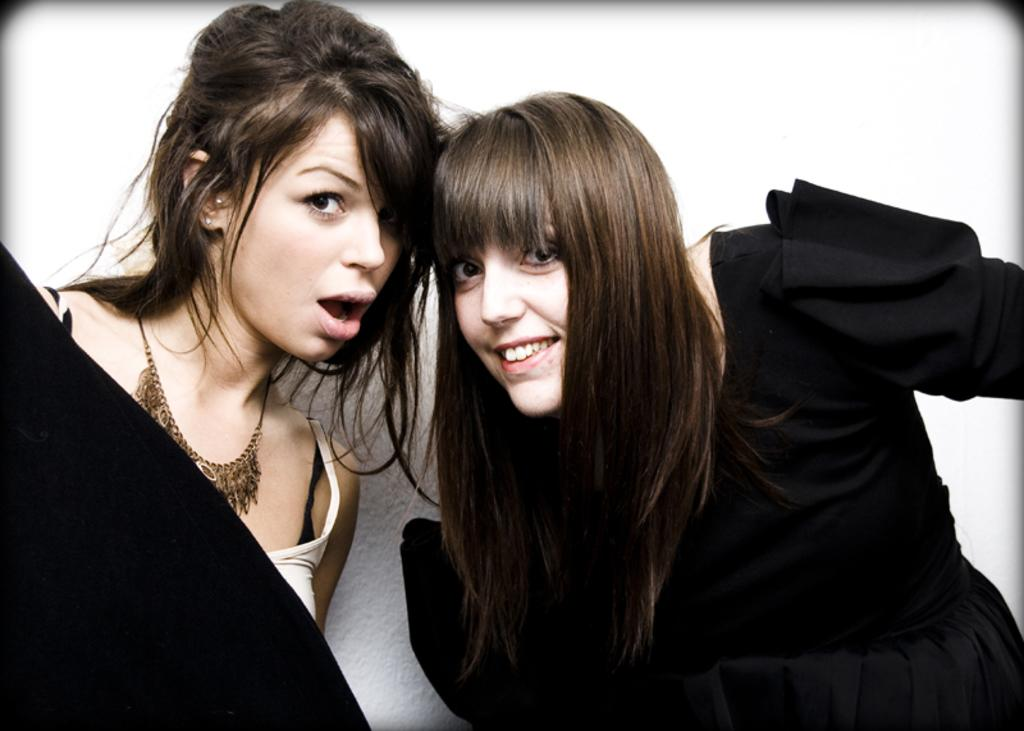How many people are in the image? There are two women in the image. What can be seen in the background of the image? The background of the image is white. What division of the company do the women in the image work for? There is no information about the company or their divisions in the image. What time of day is depicted in the image? There is no information about the time of day in the image. 